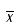Convert formula to latex. <formula><loc_0><loc_0><loc_500><loc_500>\overline { x }</formula> 